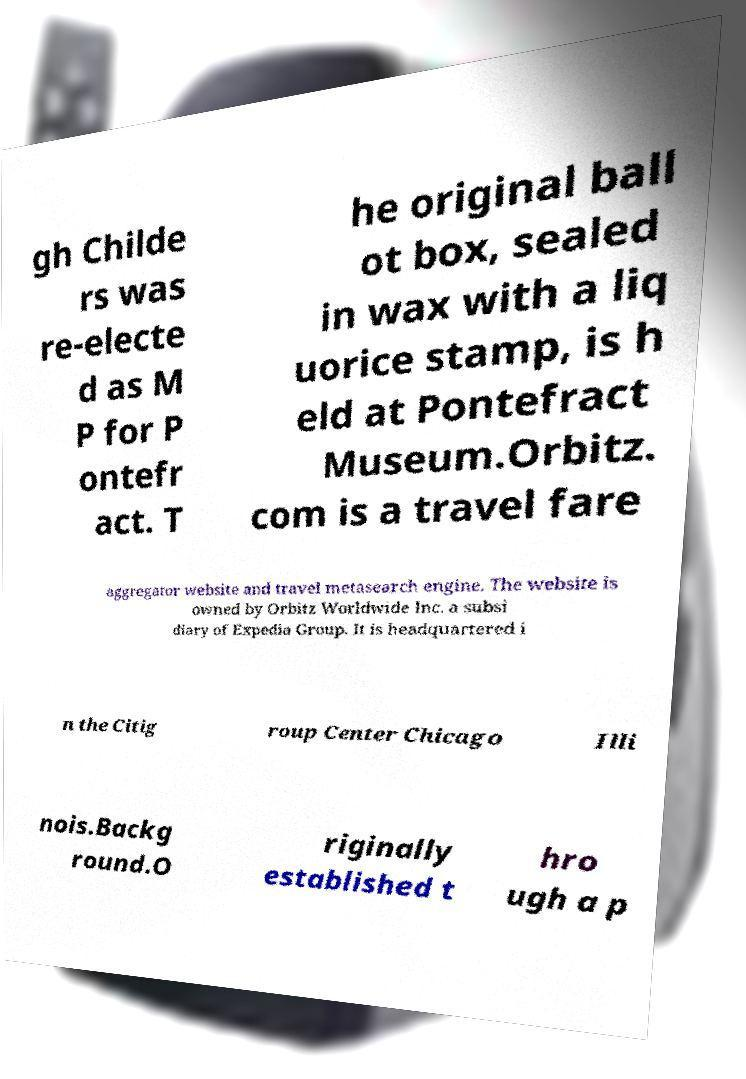What messages or text are displayed in this image? I need them in a readable, typed format. gh Childe rs was re-electe d as M P for P ontefr act. T he original ball ot box, sealed in wax with a liq uorice stamp, is h eld at Pontefract Museum.Orbitz. com is a travel fare aggregator website and travel metasearch engine. The website is owned by Orbitz Worldwide Inc. a subsi diary of Expedia Group. It is headquartered i n the Citig roup Center Chicago Illi nois.Backg round.O riginally established t hro ugh a p 